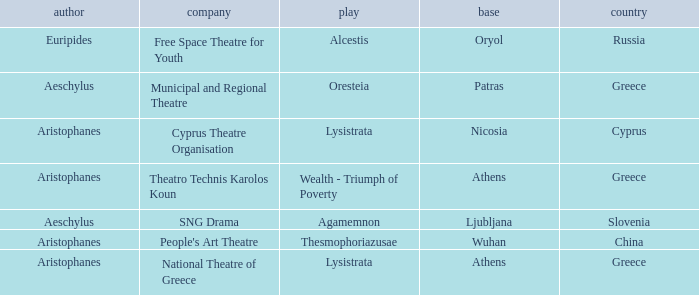What is the base when the play is thesmophoriazusae? Wuhan. 